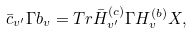Convert formula to latex. <formula><loc_0><loc_0><loc_500><loc_500>\bar { c } _ { v ^ { \prime } } \Gamma b _ { v } = T r \bar { H } _ { v ^ { \prime } } ^ { ( c ) } \Gamma H _ { v } ^ { ( b ) } X ,</formula> 